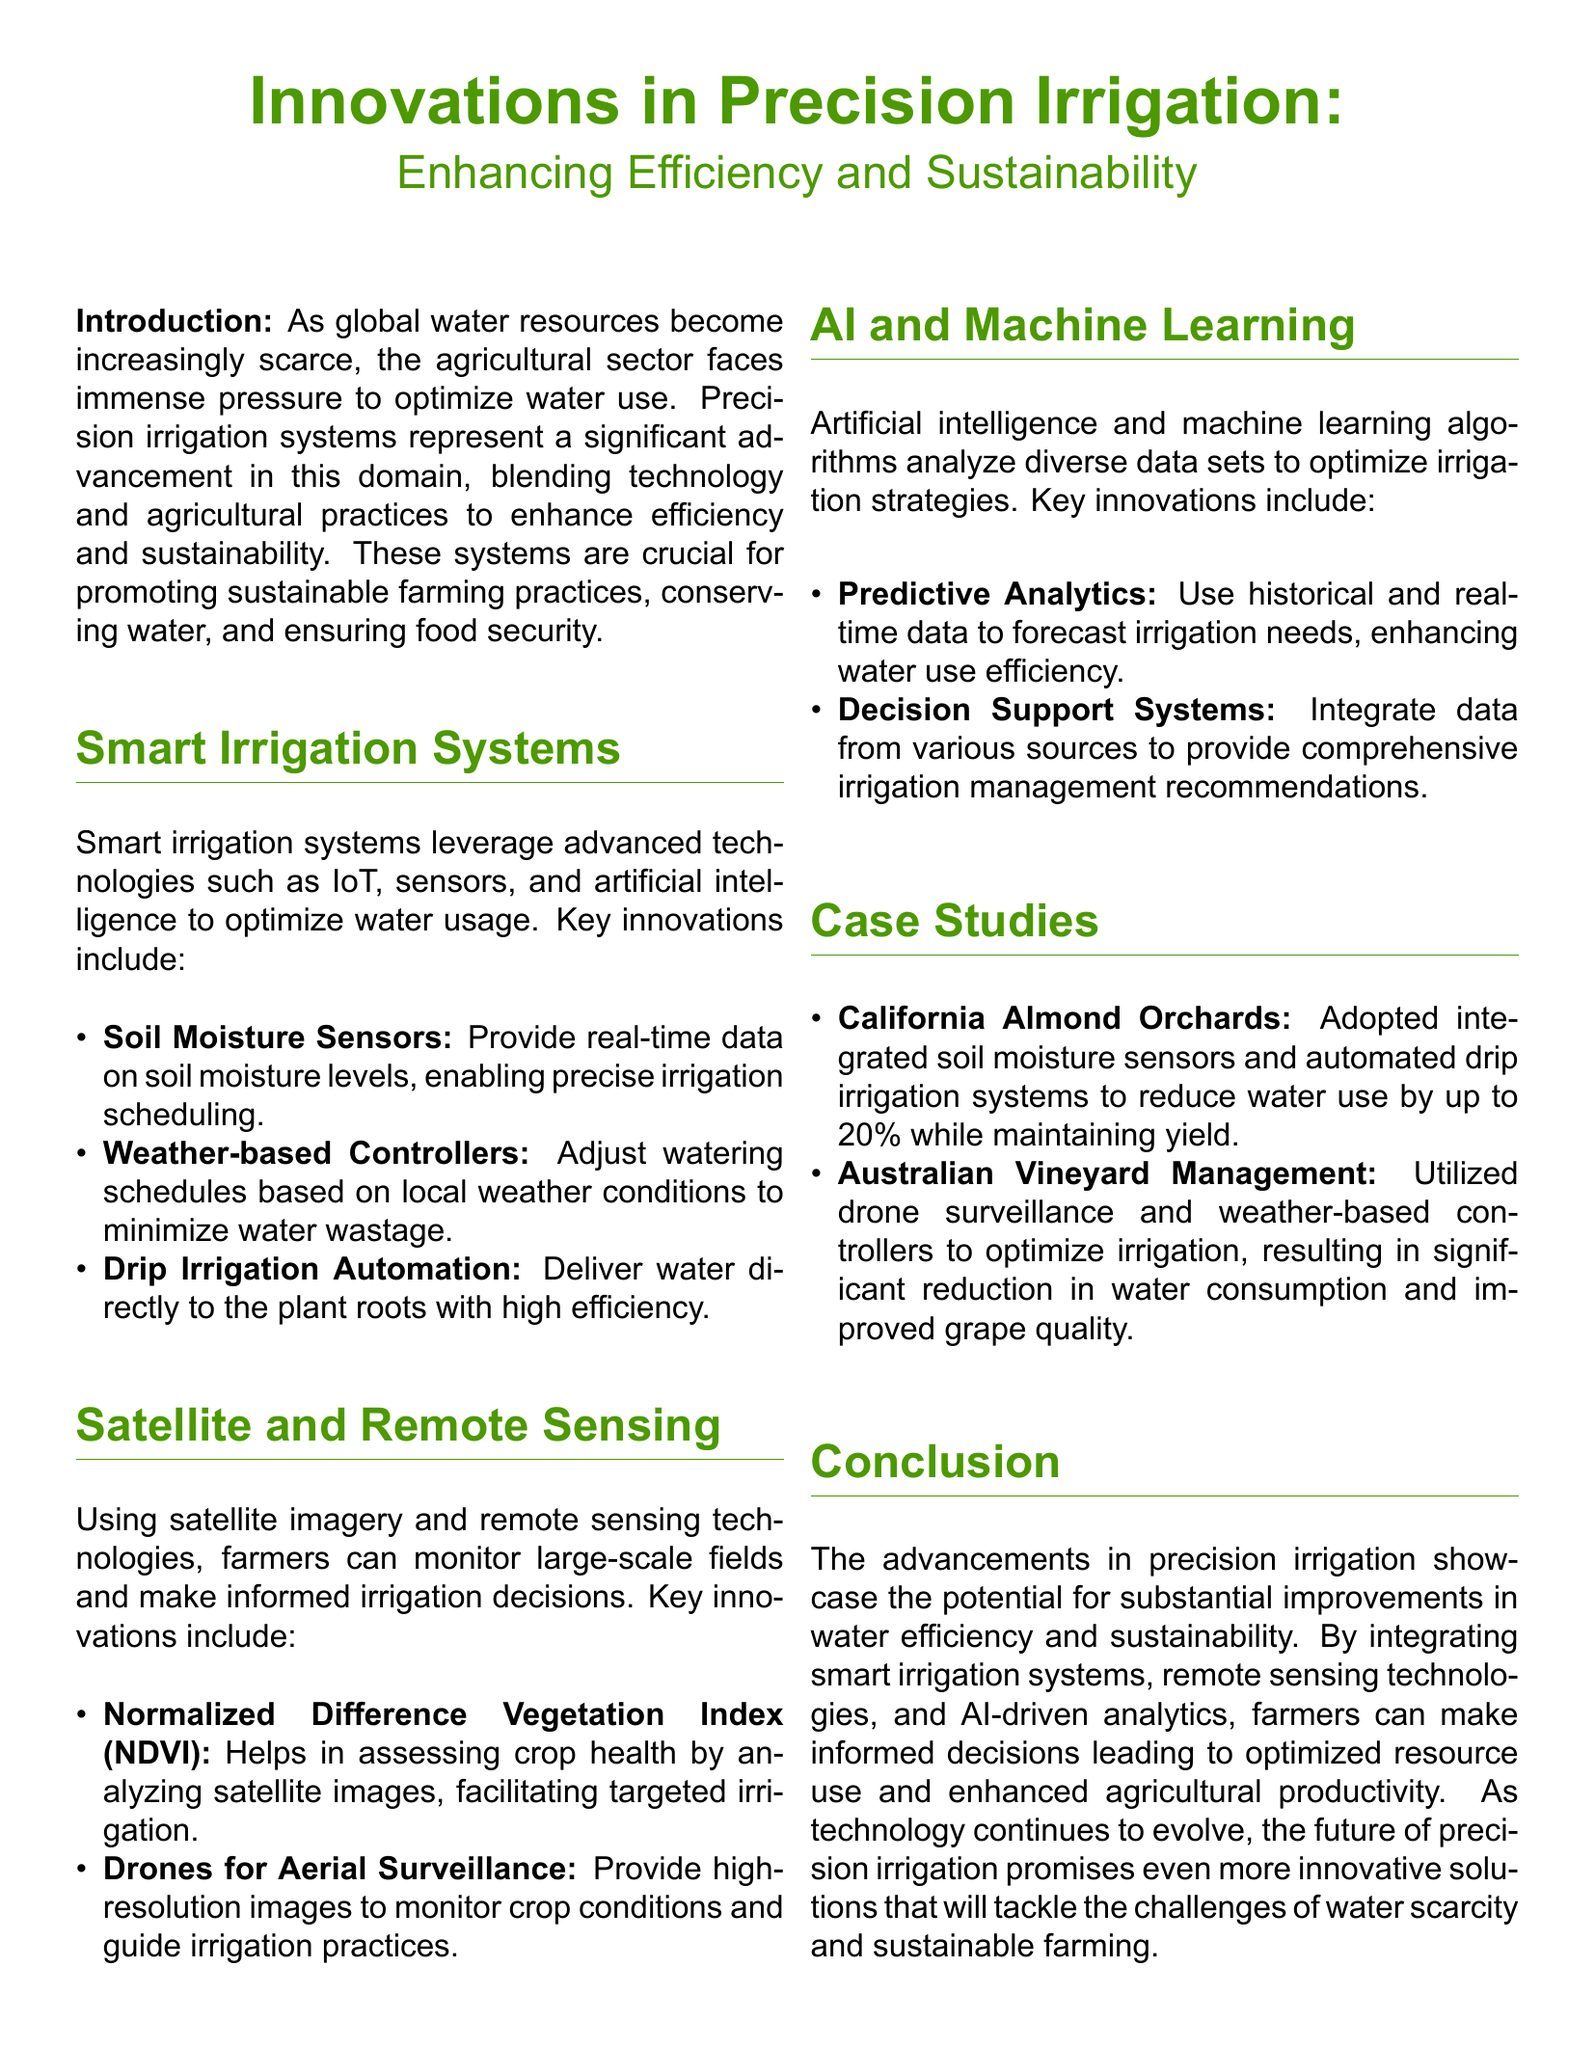what is the main focus of the whitepaper? The main focus of the whitepaper is on advancements in precision irrigation and its role in enhancing efficiency and sustainability in agriculture.
Answer: advancements in precision irrigation what technology is used in smart irrigation systems? Smart irrigation systems leverage technologies such as IoT, sensors, and artificial intelligence.
Answer: IoT, sensors, and artificial intelligence what innovation helps assess crop health using satellite images? The innovation that helps assess crop health is the Normalized Difference Vegetation Index (NDVI).
Answer: Normalized Difference Vegetation Index (NDVI) how much can water use be reduced in California Almond Orchards with new technology? In California Almond Orchards, water use can be reduced by up to 20% with integrated soil moisture sensors and automated drip irrigation systems.
Answer: 20% what role do drones play in precision irrigation? Drones provide high-resolution images for monitoring crop conditions, guiding irrigation practices.
Answer: aerial surveillance which two innovative technologies are integrated for irrigation management in the case studies? The case studies highlight the integration of soil moisture sensors and weather-based controllers for irrigation management.
Answer: soil moisture sensors and weather-based controllers how does machine learning contribute to irrigation strategies? Machine learning contributes by analyzing data to optimize irrigation strategies through predictive analytics.
Answer: predictive analytics what type of farming practices do precision irrigation systems promote? Precision irrigation systems promote sustainable farming practices.
Answer: sustainable farming practices what is one of the outcomes of using weather-based controllers in irrigation? One outcome is a significant reduction in water consumption.
Answer: significant reduction in water consumption 